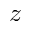<formula> <loc_0><loc_0><loc_500><loc_500>z</formula> 